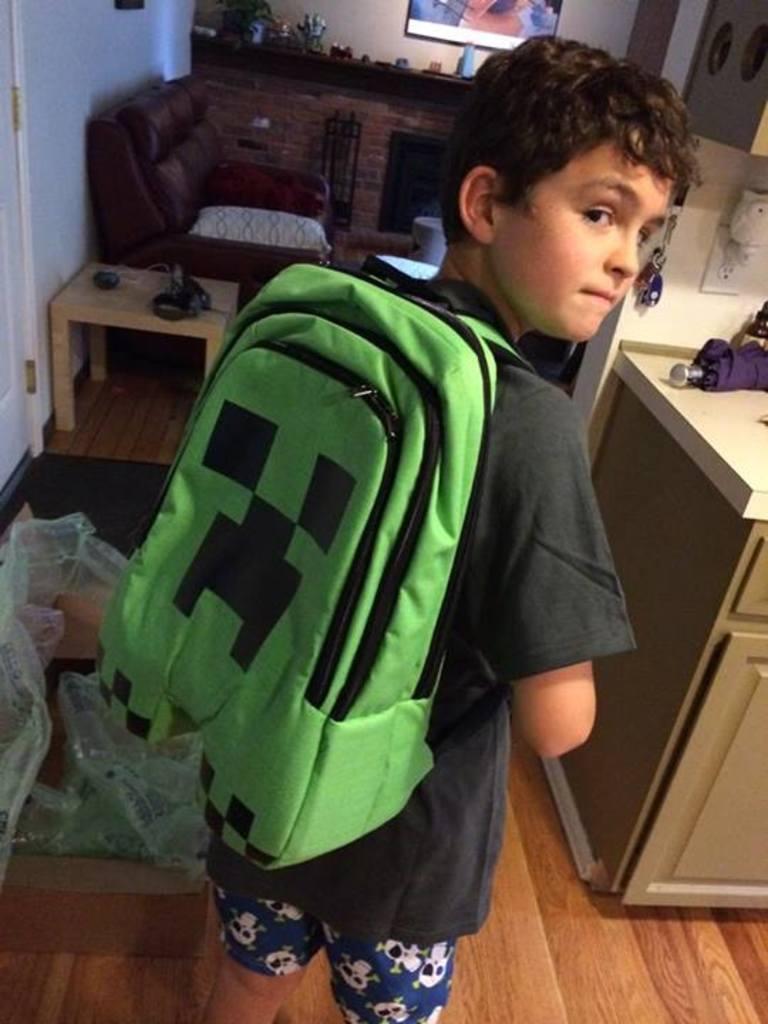Describe this image in one or two sentences. This picture is of inside the room. In the center there is a boy wearing black color t-shirt a backpack and standing. On the right there is a table on the top of which an umbrella is placed. On the left there is a couch and cushions placed on the top of the couch and there is a table. In the background we can see a wall, a television, door and some items placed on the top of the table. 